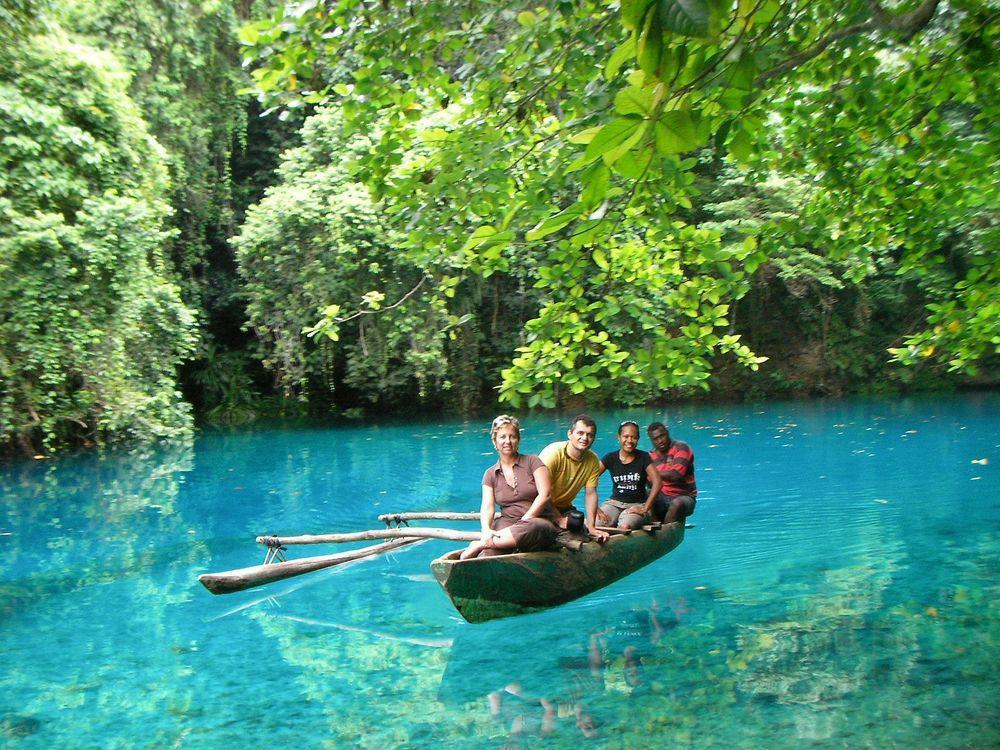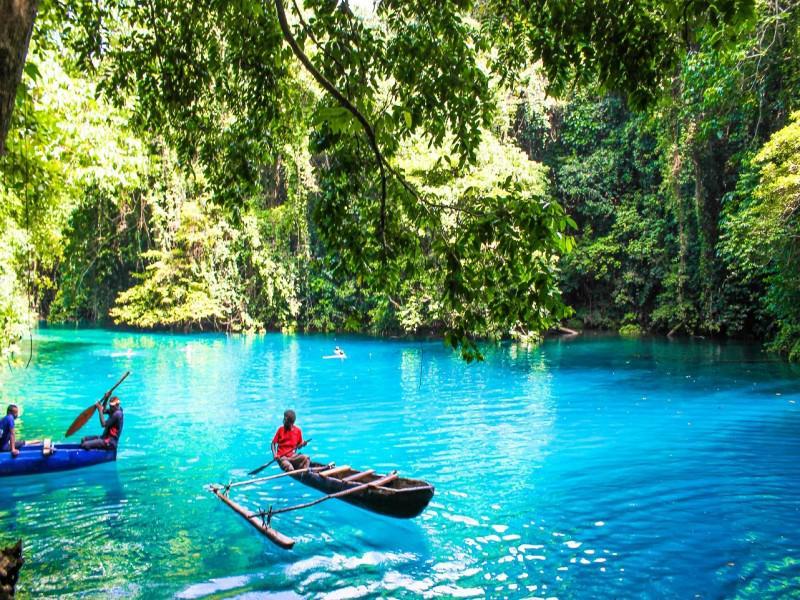The first image is the image on the left, the second image is the image on the right. Examine the images to the left and right. Is the description "Two green canoes are parallel to each other on the water, in the right image." accurate? Answer yes or no. No. The first image is the image on the left, the second image is the image on the right. Analyze the images presented: Is the assertion "One of the images features a single canoe." valid? Answer yes or no. Yes. 